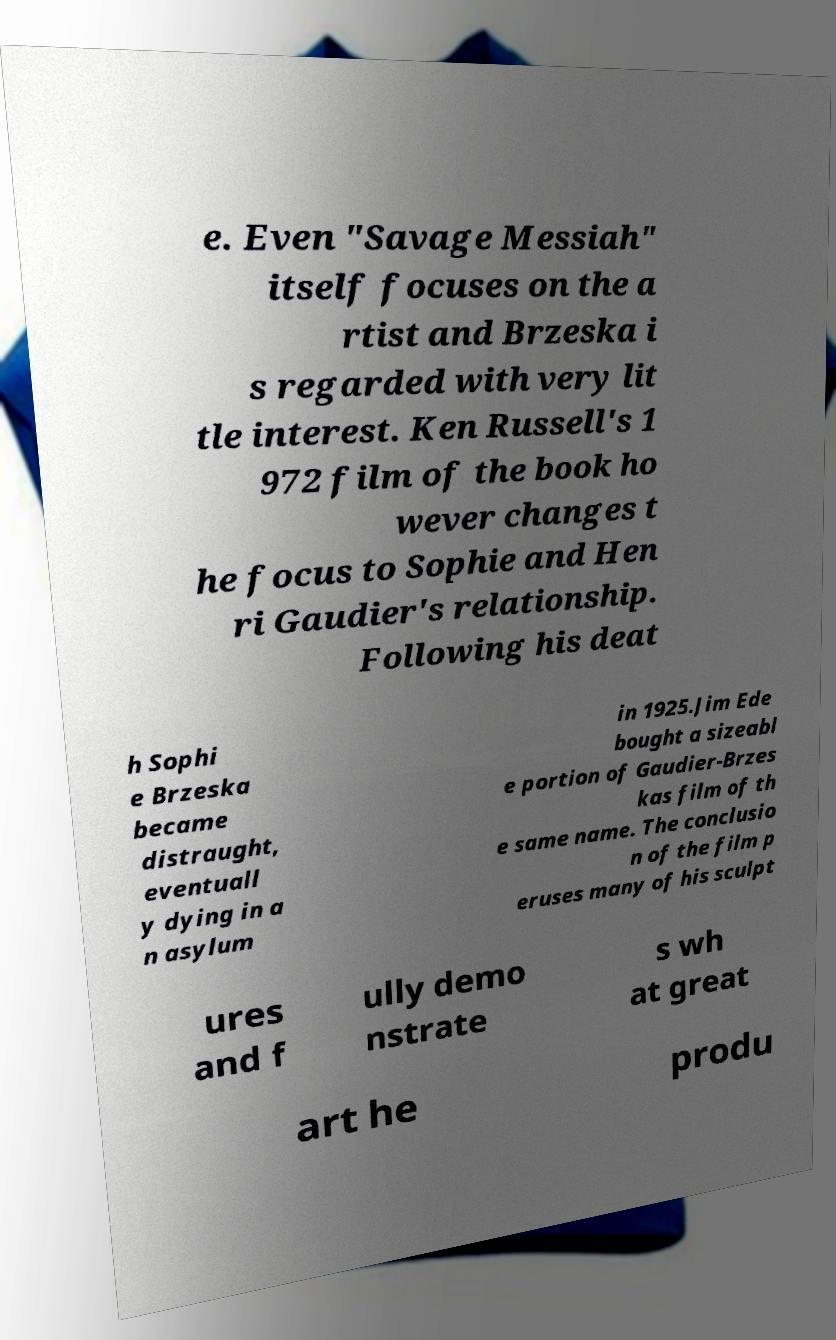For documentation purposes, I need the text within this image transcribed. Could you provide that? e. Even "Savage Messiah" itself focuses on the a rtist and Brzeska i s regarded with very lit tle interest. Ken Russell's 1 972 film of the book ho wever changes t he focus to Sophie and Hen ri Gaudier's relationship. Following his deat h Sophi e Brzeska became distraught, eventuall y dying in a n asylum in 1925.Jim Ede bought a sizeabl e portion of Gaudier-Brzes kas film of th e same name. The conclusio n of the film p eruses many of his sculpt ures and f ully demo nstrate s wh at great art he produ 